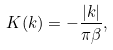<formula> <loc_0><loc_0><loc_500><loc_500>K ( k ) = - \frac { | k | } { \pi \beta } ,</formula> 